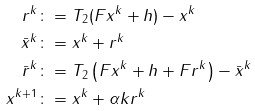Convert formula to latex. <formula><loc_0><loc_0><loc_500><loc_500>r ^ { k } & \colon = T _ { 2 } ( F x ^ { k } + h ) - x ^ { k } \\ \bar { x } ^ { k } & \colon = x ^ { k } + r ^ { k } \\ \bar { r } ^ { k } & \colon = T _ { 2 } \left ( F x ^ { k } + h + F r ^ { k } \right ) - \bar { x } ^ { k } \\ x ^ { k + 1 } & \colon = x ^ { k } + \alpha k r ^ { k }</formula> 